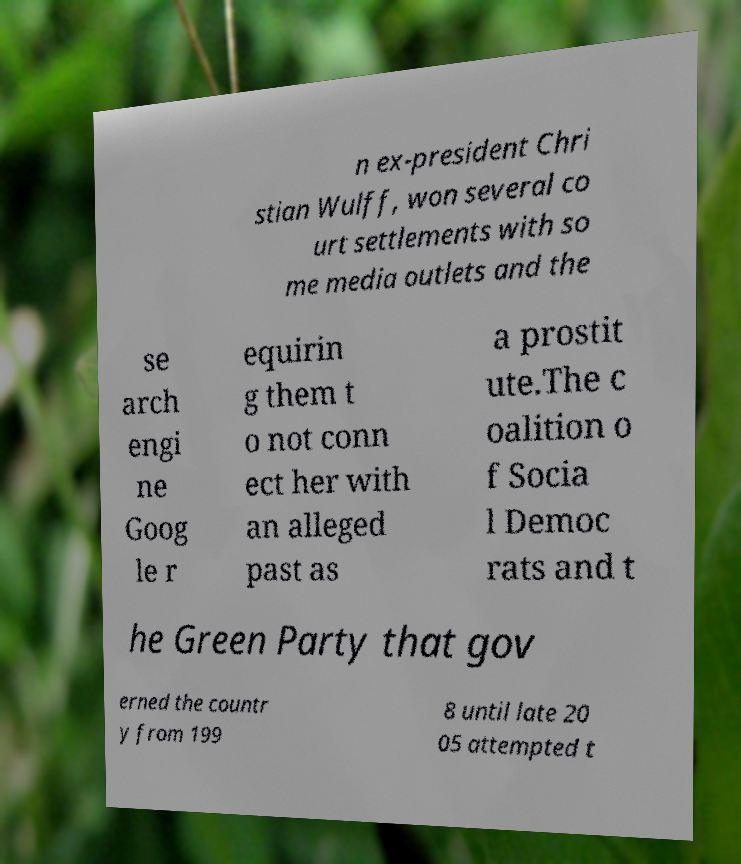Could you extract and type out the text from this image? n ex-president Chri stian Wulff, won several co urt settlements with so me media outlets and the se arch engi ne Goog le r equirin g them t o not conn ect her with an alleged past as a prostit ute.The c oalition o f Socia l Democ rats and t he Green Party that gov erned the countr y from 199 8 until late 20 05 attempted t 